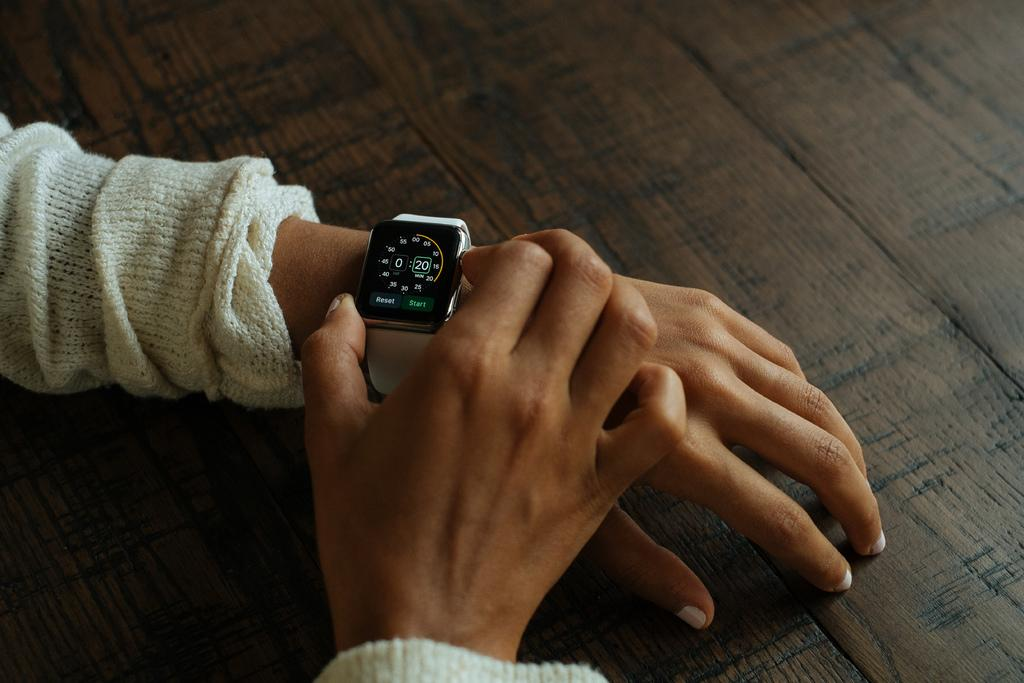<image>
Summarize the visual content of the image. Person's sleeve and a watch which has a number 20 on it. 